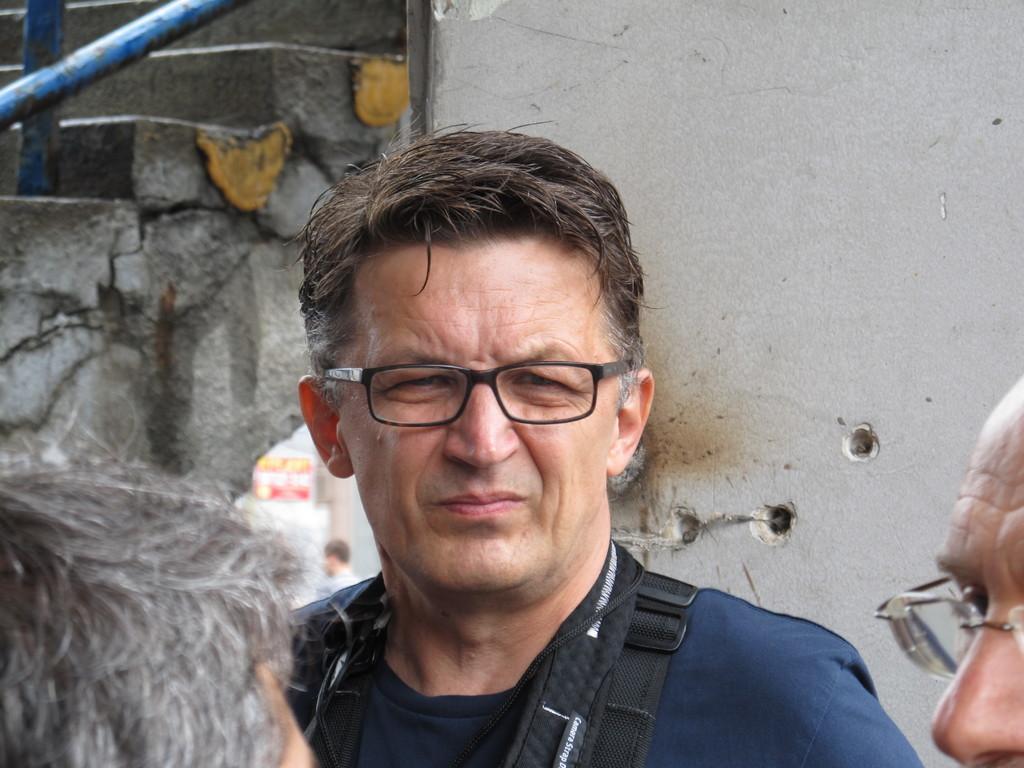Please provide a concise description of this image. In this image we can see a person wearing blue color T-shirt also wearing spectacles standing and there is black color leash on his body, at the foreground of the image we can see two persons head and face and at the background of the image there is wall and stairs. 